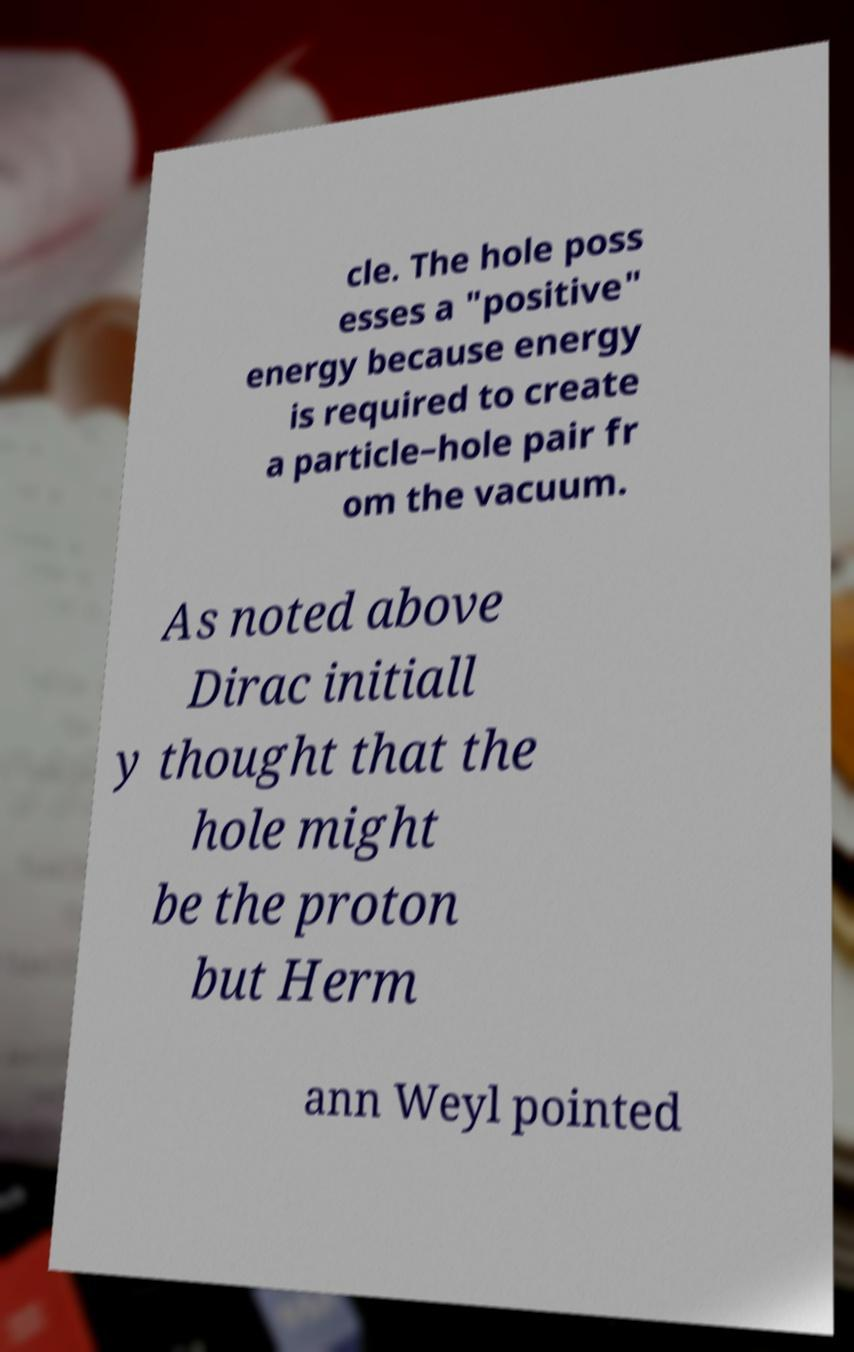For documentation purposes, I need the text within this image transcribed. Could you provide that? cle. The hole poss esses a "positive" energy because energy is required to create a particle–hole pair fr om the vacuum. As noted above Dirac initiall y thought that the hole might be the proton but Herm ann Weyl pointed 